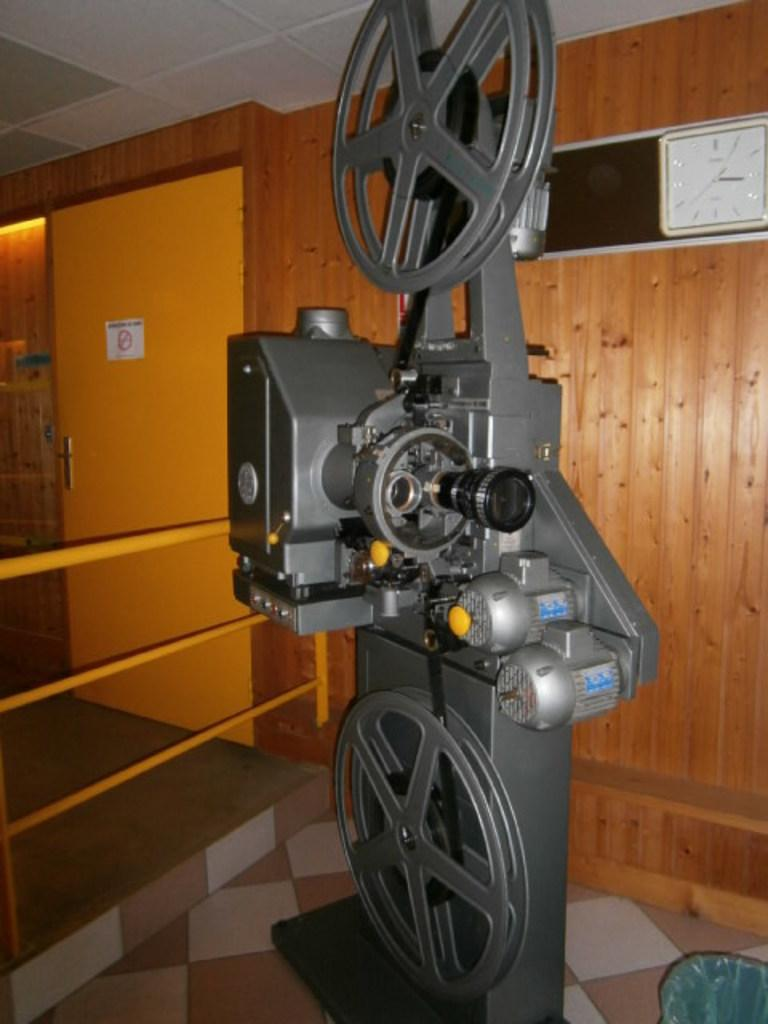What is the main object in the center of the image? There is a machine in the center of the image. What type of wall can be seen in the background of the image? There is a wooden wall in the background of the image. What architectural feature is present in the background of the image? There is a door in the background of the image. What time-related object is visible in the background of the image? There is a clock in the background of the image. What surface is at the bottom of the image? There is a floor at the bottom of the image. What surface is at the top of the image? There is a ceiling at the top of the image. How much tax is being paid on the machine in the image? There is no information about taxes in the image, as it focuses on the machine and its surroundings. 